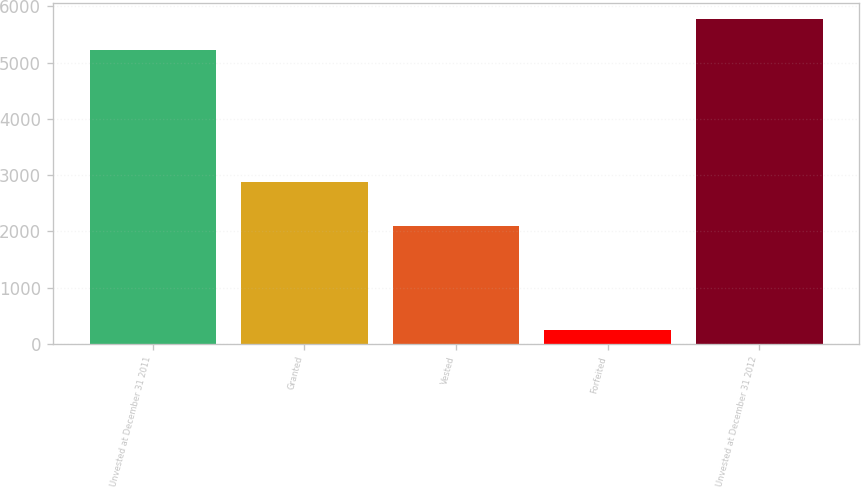Convert chart. <chart><loc_0><loc_0><loc_500><loc_500><bar_chart><fcel>Unvested at December 31 2011<fcel>Granted<fcel>Vested<fcel>Forfeited<fcel>Unvested at December 31 2012<nl><fcel>5224<fcel>2870<fcel>2101<fcel>253<fcel>5772.7<nl></chart> 